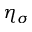Convert formula to latex. <formula><loc_0><loc_0><loc_500><loc_500>\eta _ { \sigma }</formula> 